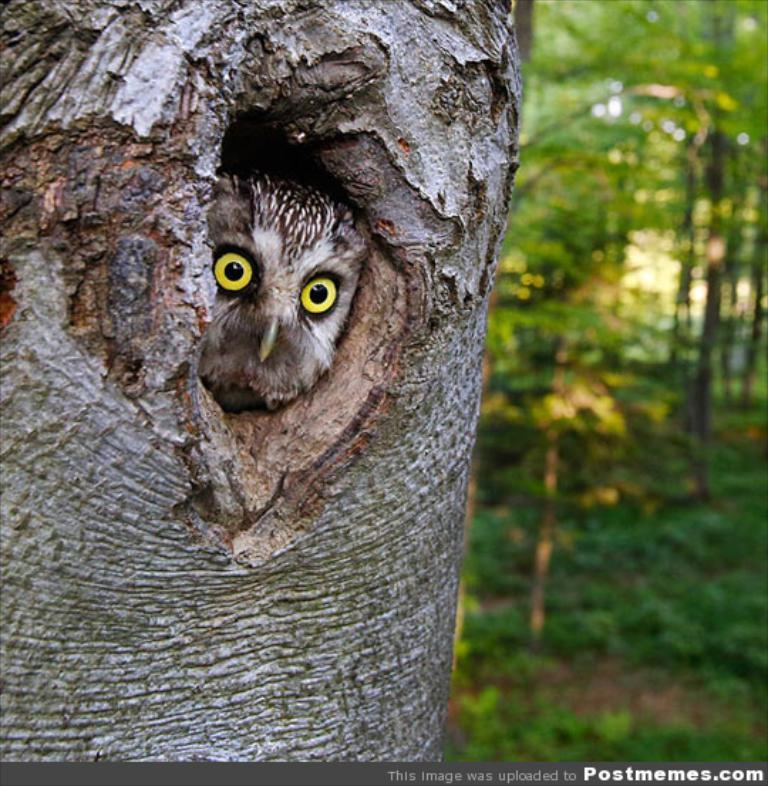What type of animal is in the image? There is an owl in the image. Where is the owl located? The owl is inside a tree. What can be seen in the background of the image? There is a group of trees in the background of the image. What type of cream is being used to paint the father's chair in the image? There is no cream, father, or chair present in the image. 